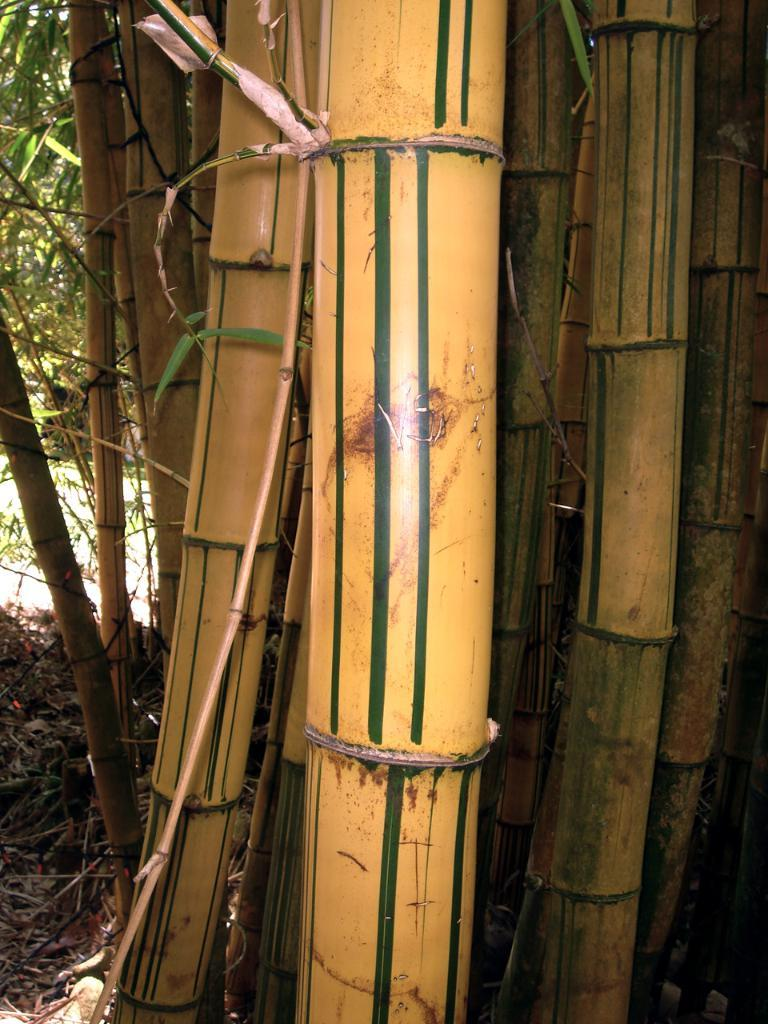What objects are present in the image? There are bamboo sticks in the image. Can you describe the appearance of the bamboo sticks? The bamboo sticks are yellow and green in color. What can be seen in the background of the image? There are trees in the background of the image. What is the color of the trees? The trees are green in color. What else is visible in the image? The ground is visible in the image. Is there a beggar asking for money near the trees in the image? There is no beggar present in the image. What type of key is used to unlock the bamboo sticks? The bamboo sticks do not require a key to unlock or open; they are not a lockable object. 